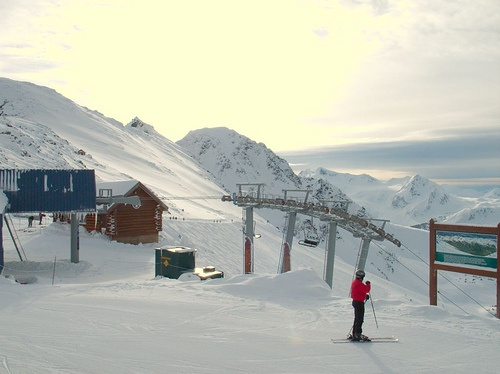Describe the objects in this image and their specific colors. I can see people in ivory, black, brown, maroon, and gray tones, skis in ivory, darkgray, gray, and black tones, and people in ivory, black, gray, and brown tones in this image. 